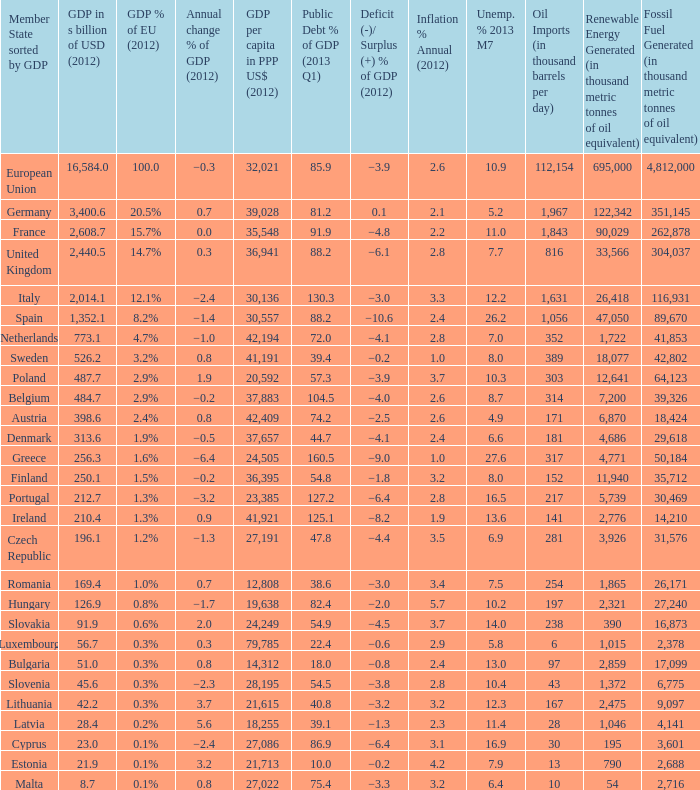What is the deficit/surplus % of the 2012 GDP of the country with a GDP in billions of USD in 2012 less than 1,352.1, a GDP per capita in PPP US dollars in 2012 greater than 21,615, public debt % of GDP in the 2013 Q1 less than 75.4, and an inflation % annual in 2012 of 2.9? −0.6. 